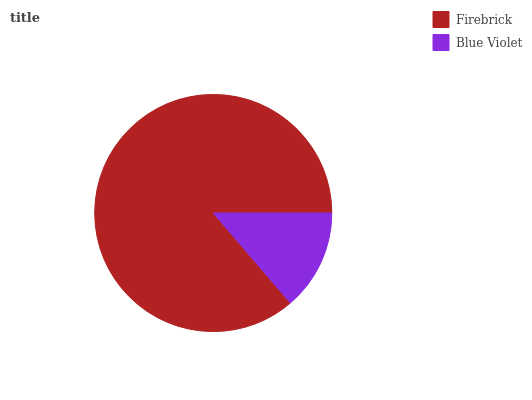Is Blue Violet the minimum?
Answer yes or no. Yes. Is Firebrick the maximum?
Answer yes or no. Yes. Is Blue Violet the maximum?
Answer yes or no. No. Is Firebrick greater than Blue Violet?
Answer yes or no. Yes. Is Blue Violet less than Firebrick?
Answer yes or no. Yes. Is Blue Violet greater than Firebrick?
Answer yes or no. No. Is Firebrick less than Blue Violet?
Answer yes or no. No. Is Firebrick the high median?
Answer yes or no. Yes. Is Blue Violet the low median?
Answer yes or no. Yes. Is Blue Violet the high median?
Answer yes or no. No. Is Firebrick the low median?
Answer yes or no. No. 